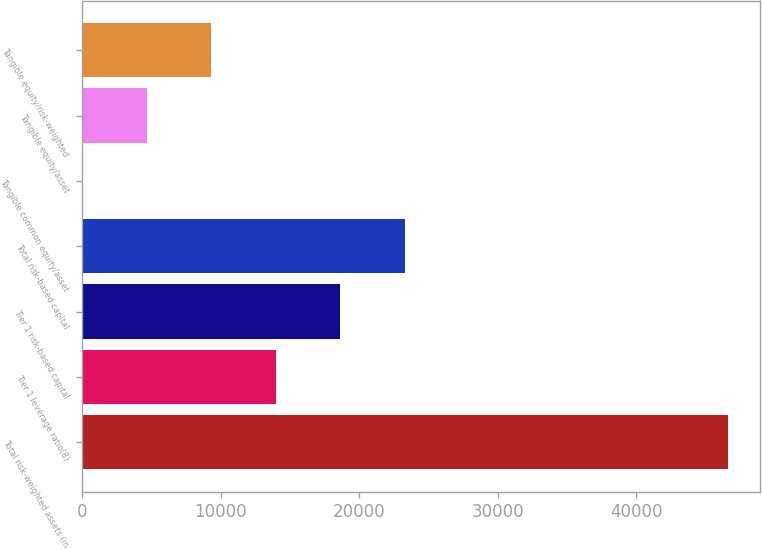Convert chart. <chart><loc_0><loc_0><loc_500><loc_500><bar_chart><fcel>Total risk-weighted assets (in<fcel>Tier 1 leverage ratio(8)<fcel>Tier 1 risk-based capital<fcel>Total risk-based capital<fcel>Tangible common equity/asset<fcel>Tangible equity/asset<fcel>Tangible equity/risk-weighted<nl><fcel>46608<fcel>13985.8<fcel>18646.1<fcel>23306.4<fcel>4.88<fcel>4665.19<fcel>9325.5<nl></chart> 